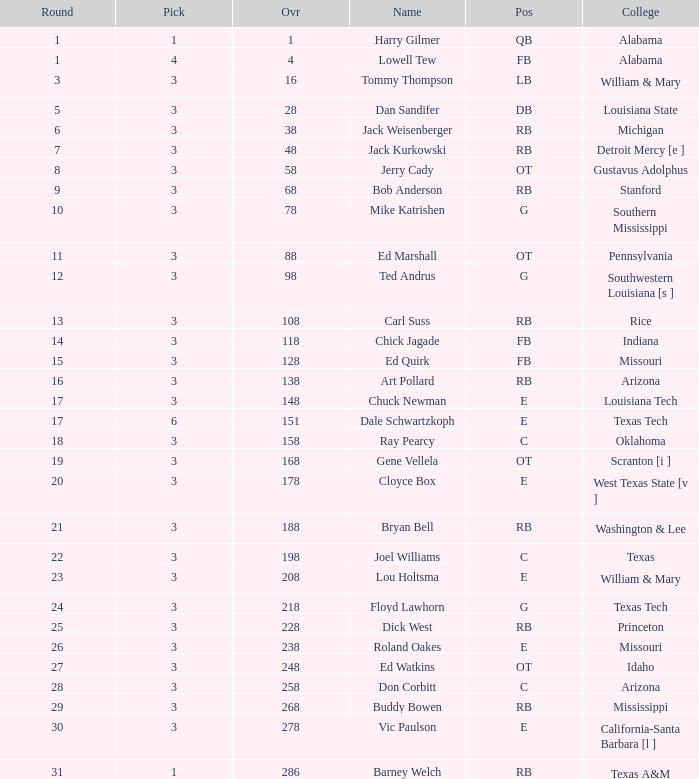Which Overall has a Name of bob anderson, and a Round smaller than 9? None. 